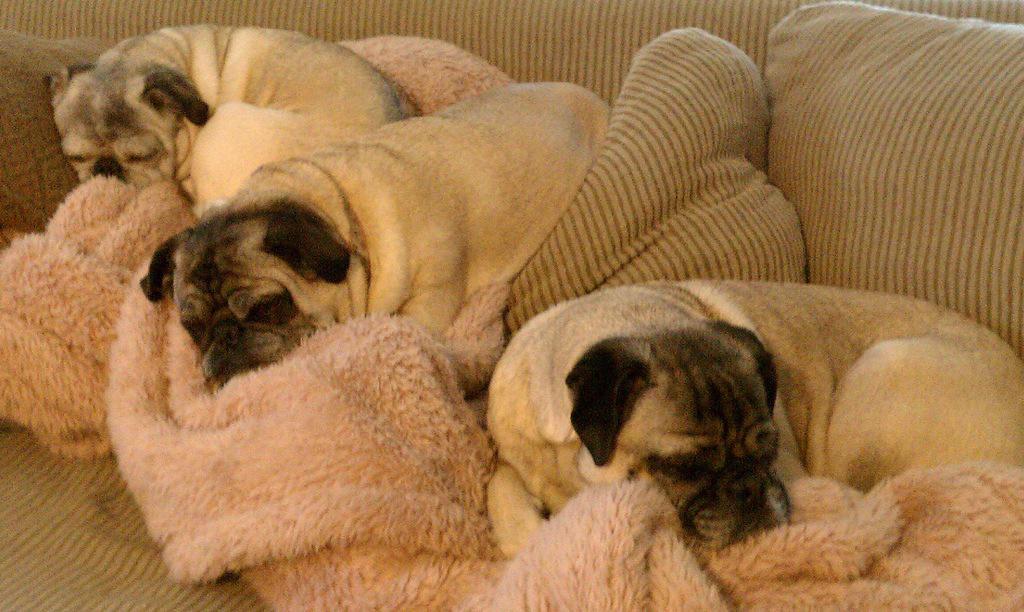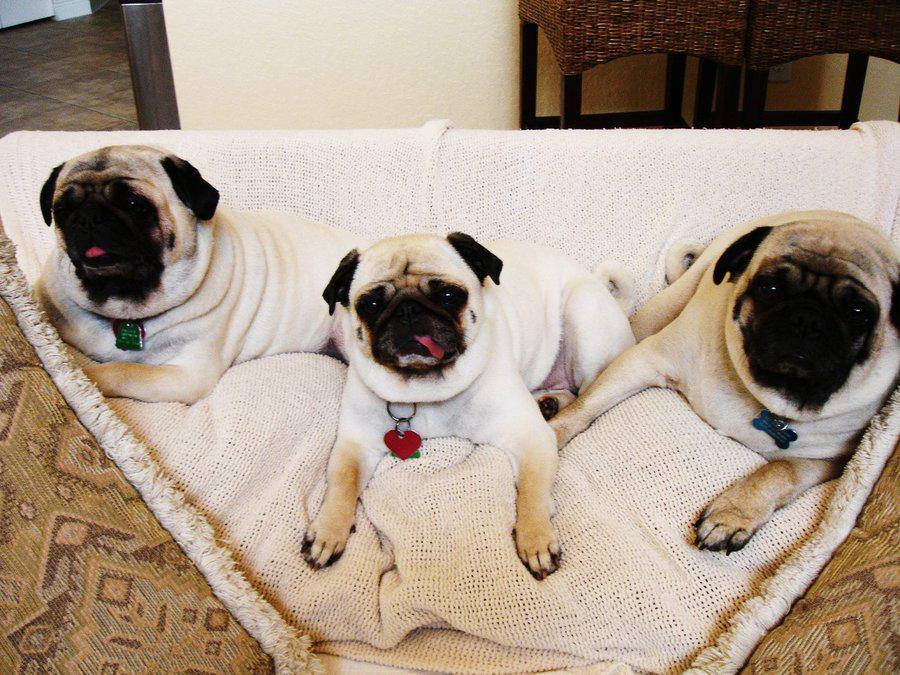The first image is the image on the left, the second image is the image on the right. Examine the images to the left and right. Is the description "One image shows a trio of pugs snoozing on a beige cushioned item, and the other image shows a row of three pugs, with paws draped on something white." accurate? Answer yes or no. Yes. The first image is the image on the left, the second image is the image on the right. Analyze the images presented: Is the assertion "Three dogs have their front paws off the ground." valid? Answer yes or no. No. 